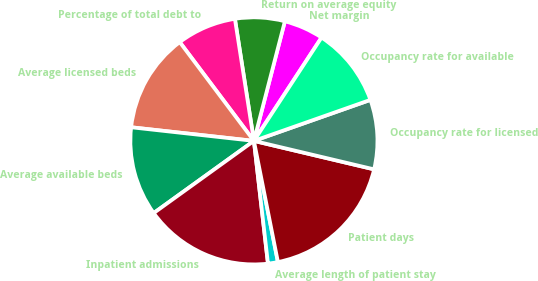Convert chart to OTSL. <chart><loc_0><loc_0><loc_500><loc_500><pie_chart><fcel>Net margin<fcel>Return on average equity<fcel>Percentage of total debt to<fcel>Average licensed beds<fcel>Average available beds<fcel>Inpatient admissions<fcel>Average length of patient stay<fcel>Patient days<fcel>Occupancy rate for licensed<fcel>Occupancy rate for available<nl><fcel>5.19%<fcel>6.49%<fcel>7.79%<fcel>12.99%<fcel>11.69%<fcel>16.88%<fcel>1.3%<fcel>18.18%<fcel>9.09%<fcel>10.39%<nl></chart> 